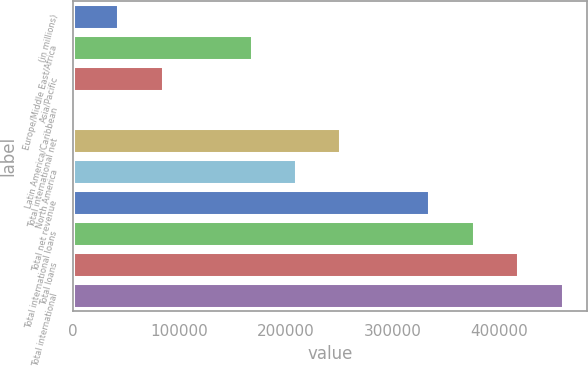Convert chart to OTSL. <chart><loc_0><loc_0><loc_500><loc_500><bar_chart><fcel>(in millions)<fcel>Europe/Middle East/Africa<fcel>Asia/Pacific<fcel>Latin America/Caribbean<fcel>Total international net<fcel>North America<fcel>Total net revenue<fcel>Total international loans<fcel>Total loans<fcel>Total international<nl><fcel>42798<fcel>167655<fcel>84417<fcel>1179<fcel>250893<fcel>209274<fcel>334131<fcel>375750<fcel>417369<fcel>458988<nl></chart> 